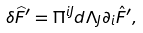Convert formula to latex. <formula><loc_0><loc_0><loc_500><loc_500>\delta \widehat { F } ^ { \prime } = \Pi ^ { i J } d \Lambda _ { J } \partial _ { i } \hat { F } ^ { \prime } ,</formula> 